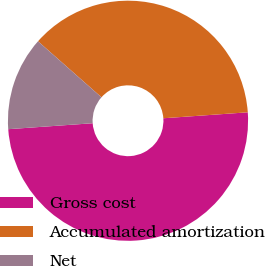Convert chart. <chart><loc_0><loc_0><loc_500><loc_500><pie_chart><fcel>Gross cost<fcel>Accumulated amortization<fcel>Net<nl><fcel>50.0%<fcel>37.37%<fcel>12.63%<nl></chart> 